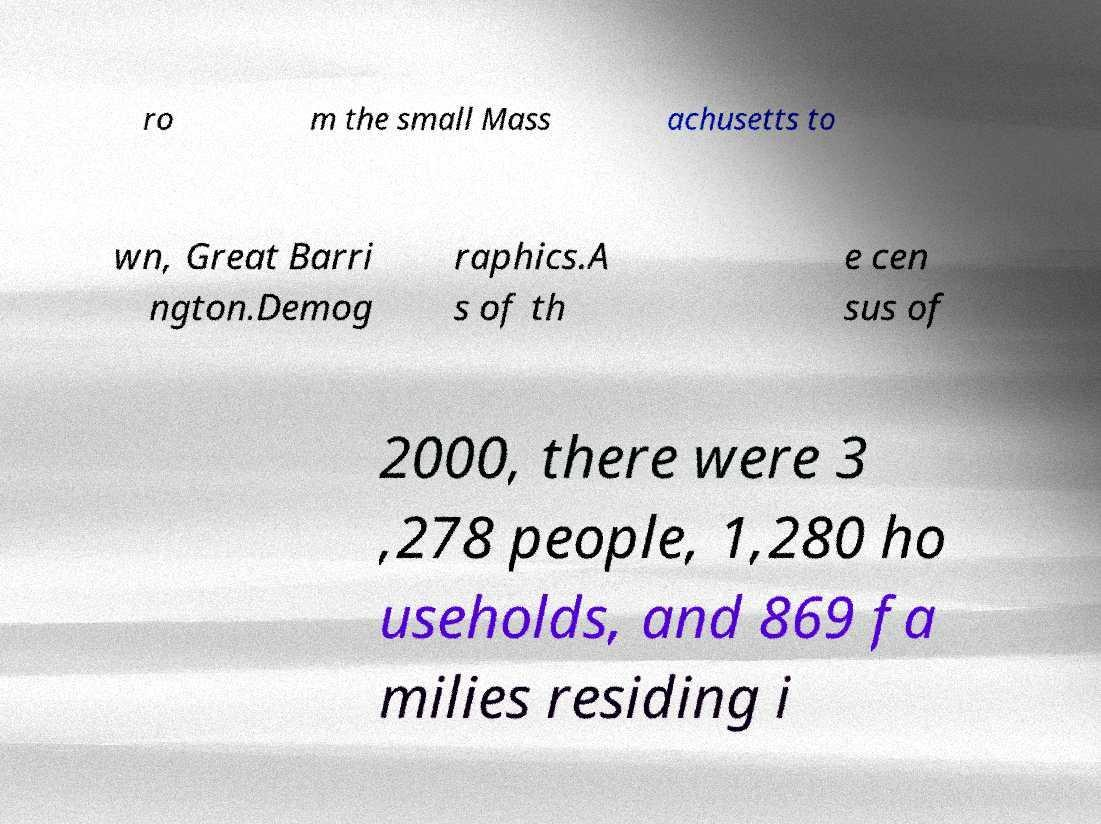Please read and relay the text visible in this image. What does it say? ro m the small Mass achusetts to wn, Great Barri ngton.Demog raphics.A s of th e cen sus of 2000, there were 3 ,278 people, 1,280 ho useholds, and 869 fa milies residing i 